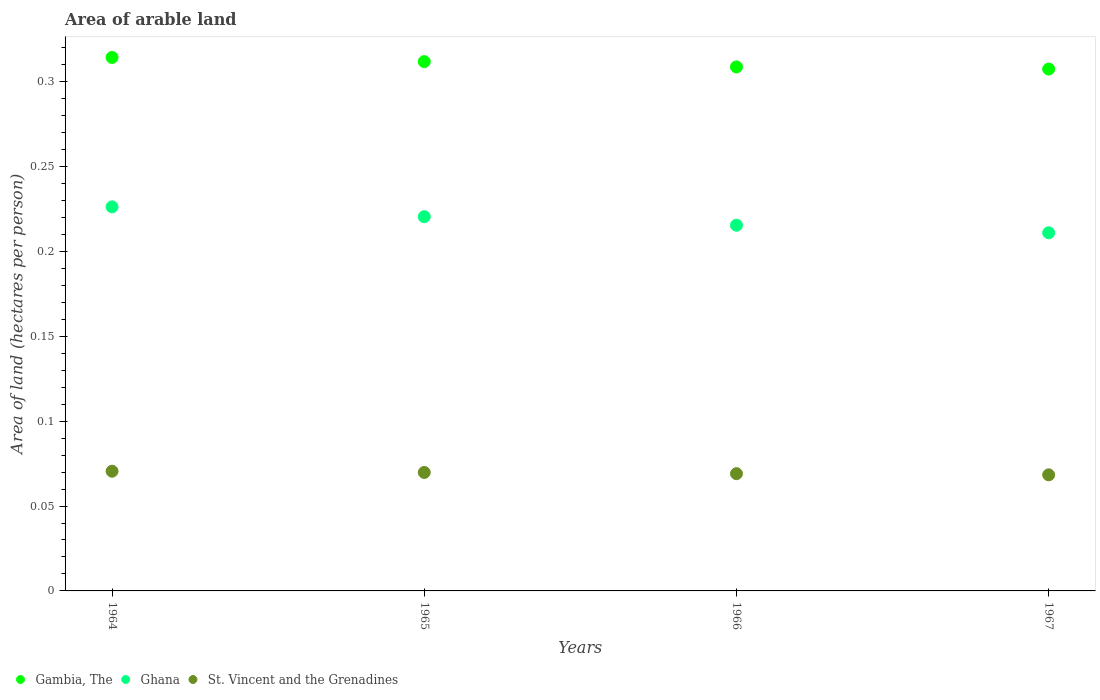How many different coloured dotlines are there?
Offer a terse response. 3. What is the total arable land in St. Vincent and the Grenadines in 1964?
Make the answer very short. 0.07. Across all years, what is the maximum total arable land in St. Vincent and the Grenadines?
Your answer should be compact. 0.07. Across all years, what is the minimum total arable land in St. Vincent and the Grenadines?
Your answer should be very brief. 0.07. In which year was the total arable land in Gambia, The maximum?
Make the answer very short. 1964. In which year was the total arable land in Ghana minimum?
Keep it short and to the point. 1967. What is the total total arable land in Ghana in the graph?
Offer a terse response. 0.87. What is the difference between the total arable land in Ghana in 1965 and that in 1966?
Provide a short and direct response. 0.01. What is the difference between the total arable land in Ghana in 1966 and the total arable land in Gambia, The in 1967?
Your answer should be compact. -0.09. What is the average total arable land in Gambia, The per year?
Provide a succinct answer. 0.31. In the year 1964, what is the difference between the total arable land in St. Vincent and the Grenadines and total arable land in Ghana?
Offer a very short reply. -0.16. What is the ratio of the total arable land in Gambia, The in 1964 to that in 1966?
Provide a succinct answer. 1.02. Is the total arable land in Ghana in 1966 less than that in 1967?
Ensure brevity in your answer.  No. What is the difference between the highest and the second highest total arable land in Gambia, The?
Your answer should be compact. 0. What is the difference between the highest and the lowest total arable land in Gambia, The?
Make the answer very short. 0.01. In how many years, is the total arable land in St. Vincent and the Grenadines greater than the average total arable land in St. Vincent and the Grenadines taken over all years?
Offer a terse response. 2. Is the sum of the total arable land in St. Vincent and the Grenadines in 1965 and 1966 greater than the maximum total arable land in Ghana across all years?
Provide a short and direct response. No. Does the total arable land in St. Vincent and the Grenadines monotonically increase over the years?
Provide a short and direct response. No. Is the total arable land in Gambia, The strictly less than the total arable land in St. Vincent and the Grenadines over the years?
Your answer should be compact. No. How many years are there in the graph?
Your answer should be very brief. 4. What is the difference between two consecutive major ticks on the Y-axis?
Offer a terse response. 0.05. Are the values on the major ticks of Y-axis written in scientific E-notation?
Give a very brief answer. No. How many legend labels are there?
Keep it short and to the point. 3. How are the legend labels stacked?
Ensure brevity in your answer.  Horizontal. What is the title of the graph?
Your answer should be very brief. Area of arable land. Does "Caribbean small states" appear as one of the legend labels in the graph?
Offer a very short reply. No. What is the label or title of the Y-axis?
Your response must be concise. Area of land (hectares per person). What is the Area of land (hectares per person) of Gambia, The in 1964?
Ensure brevity in your answer.  0.31. What is the Area of land (hectares per person) in Ghana in 1964?
Your answer should be very brief. 0.23. What is the Area of land (hectares per person) in St. Vincent and the Grenadines in 1964?
Offer a terse response. 0.07. What is the Area of land (hectares per person) in Gambia, The in 1965?
Provide a succinct answer. 0.31. What is the Area of land (hectares per person) in Ghana in 1965?
Give a very brief answer. 0.22. What is the Area of land (hectares per person) of St. Vincent and the Grenadines in 1965?
Provide a succinct answer. 0.07. What is the Area of land (hectares per person) of Gambia, The in 1966?
Keep it short and to the point. 0.31. What is the Area of land (hectares per person) in Ghana in 1966?
Offer a very short reply. 0.22. What is the Area of land (hectares per person) of St. Vincent and the Grenadines in 1966?
Offer a very short reply. 0.07. What is the Area of land (hectares per person) of Gambia, The in 1967?
Offer a very short reply. 0.31. What is the Area of land (hectares per person) of Ghana in 1967?
Keep it short and to the point. 0.21. What is the Area of land (hectares per person) of St. Vincent and the Grenadines in 1967?
Your answer should be very brief. 0.07. Across all years, what is the maximum Area of land (hectares per person) of Gambia, The?
Offer a terse response. 0.31. Across all years, what is the maximum Area of land (hectares per person) in Ghana?
Provide a short and direct response. 0.23. Across all years, what is the maximum Area of land (hectares per person) in St. Vincent and the Grenadines?
Provide a succinct answer. 0.07. Across all years, what is the minimum Area of land (hectares per person) in Gambia, The?
Your answer should be very brief. 0.31. Across all years, what is the minimum Area of land (hectares per person) of Ghana?
Ensure brevity in your answer.  0.21. Across all years, what is the minimum Area of land (hectares per person) in St. Vincent and the Grenadines?
Give a very brief answer. 0.07. What is the total Area of land (hectares per person) of Gambia, The in the graph?
Make the answer very short. 1.24. What is the total Area of land (hectares per person) in Ghana in the graph?
Your answer should be compact. 0.87. What is the total Area of land (hectares per person) of St. Vincent and the Grenadines in the graph?
Give a very brief answer. 0.28. What is the difference between the Area of land (hectares per person) of Gambia, The in 1964 and that in 1965?
Keep it short and to the point. 0. What is the difference between the Area of land (hectares per person) in Ghana in 1964 and that in 1965?
Give a very brief answer. 0.01. What is the difference between the Area of land (hectares per person) in St. Vincent and the Grenadines in 1964 and that in 1965?
Make the answer very short. 0. What is the difference between the Area of land (hectares per person) of Gambia, The in 1964 and that in 1966?
Provide a short and direct response. 0.01. What is the difference between the Area of land (hectares per person) of Ghana in 1964 and that in 1966?
Ensure brevity in your answer.  0.01. What is the difference between the Area of land (hectares per person) in St. Vincent and the Grenadines in 1964 and that in 1966?
Make the answer very short. 0. What is the difference between the Area of land (hectares per person) of Gambia, The in 1964 and that in 1967?
Your response must be concise. 0.01. What is the difference between the Area of land (hectares per person) of Ghana in 1964 and that in 1967?
Make the answer very short. 0.02. What is the difference between the Area of land (hectares per person) in St. Vincent and the Grenadines in 1964 and that in 1967?
Ensure brevity in your answer.  0. What is the difference between the Area of land (hectares per person) in Gambia, The in 1965 and that in 1966?
Ensure brevity in your answer.  0. What is the difference between the Area of land (hectares per person) in Ghana in 1965 and that in 1966?
Your answer should be very brief. 0.01. What is the difference between the Area of land (hectares per person) of St. Vincent and the Grenadines in 1965 and that in 1966?
Your answer should be compact. 0. What is the difference between the Area of land (hectares per person) of Gambia, The in 1965 and that in 1967?
Keep it short and to the point. 0. What is the difference between the Area of land (hectares per person) of Ghana in 1965 and that in 1967?
Give a very brief answer. 0.01. What is the difference between the Area of land (hectares per person) in St. Vincent and the Grenadines in 1965 and that in 1967?
Make the answer very short. 0. What is the difference between the Area of land (hectares per person) of Gambia, The in 1966 and that in 1967?
Provide a short and direct response. 0. What is the difference between the Area of land (hectares per person) of Ghana in 1966 and that in 1967?
Your response must be concise. 0. What is the difference between the Area of land (hectares per person) in St. Vincent and the Grenadines in 1966 and that in 1967?
Ensure brevity in your answer.  0. What is the difference between the Area of land (hectares per person) of Gambia, The in 1964 and the Area of land (hectares per person) of Ghana in 1965?
Ensure brevity in your answer.  0.09. What is the difference between the Area of land (hectares per person) in Gambia, The in 1964 and the Area of land (hectares per person) in St. Vincent and the Grenadines in 1965?
Your answer should be compact. 0.24. What is the difference between the Area of land (hectares per person) in Ghana in 1964 and the Area of land (hectares per person) in St. Vincent and the Grenadines in 1965?
Your answer should be compact. 0.16. What is the difference between the Area of land (hectares per person) of Gambia, The in 1964 and the Area of land (hectares per person) of Ghana in 1966?
Make the answer very short. 0.1. What is the difference between the Area of land (hectares per person) in Gambia, The in 1964 and the Area of land (hectares per person) in St. Vincent and the Grenadines in 1966?
Give a very brief answer. 0.25. What is the difference between the Area of land (hectares per person) in Ghana in 1964 and the Area of land (hectares per person) in St. Vincent and the Grenadines in 1966?
Your answer should be very brief. 0.16. What is the difference between the Area of land (hectares per person) in Gambia, The in 1964 and the Area of land (hectares per person) in Ghana in 1967?
Give a very brief answer. 0.1. What is the difference between the Area of land (hectares per person) in Gambia, The in 1964 and the Area of land (hectares per person) in St. Vincent and the Grenadines in 1967?
Offer a terse response. 0.25. What is the difference between the Area of land (hectares per person) of Ghana in 1964 and the Area of land (hectares per person) of St. Vincent and the Grenadines in 1967?
Provide a short and direct response. 0.16. What is the difference between the Area of land (hectares per person) of Gambia, The in 1965 and the Area of land (hectares per person) of Ghana in 1966?
Offer a very short reply. 0.1. What is the difference between the Area of land (hectares per person) of Gambia, The in 1965 and the Area of land (hectares per person) of St. Vincent and the Grenadines in 1966?
Keep it short and to the point. 0.24. What is the difference between the Area of land (hectares per person) in Ghana in 1965 and the Area of land (hectares per person) in St. Vincent and the Grenadines in 1966?
Offer a terse response. 0.15. What is the difference between the Area of land (hectares per person) in Gambia, The in 1965 and the Area of land (hectares per person) in Ghana in 1967?
Provide a succinct answer. 0.1. What is the difference between the Area of land (hectares per person) of Gambia, The in 1965 and the Area of land (hectares per person) of St. Vincent and the Grenadines in 1967?
Your response must be concise. 0.24. What is the difference between the Area of land (hectares per person) of Ghana in 1965 and the Area of land (hectares per person) of St. Vincent and the Grenadines in 1967?
Offer a terse response. 0.15. What is the difference between the Area of land (hectares per person) in Gambia, The in 1966 and the Area of land (hectares per person) in Ghana in 1967?
Offer a very short reply. 0.1. What is the difference between the Area of land (hectares per person) of Gambia, The in 1966 and the Area of land (hectares per person) of St. Vincent and the Grenadines in 1967?
Offer a terse response. 0.24. What is the difference between the Area of land (hectares per person) of Ghana in 1966 and the Area of land (hectares per person) of St. Vincent and the Grenadines in 1967?
Provide a short and direct response. 0.15. What is the average Area of land (hectares per person) of Gambia, The per year?
Ensure brevity in your answer.  0.31. What is the average Area of land (hectares per person) in Ghana per year?
Your answer should be very brief. 0.22. What is the average Area of land (hectares per person) in St. Vincent and the Grenadines per year?
Offer a terse response. 0.07. In the year 1964, what is the difference between the Area of land (hectares per person) of Gambia, The and Area of land (hectares per person) of Ghana?
Make the answer very short. 0.09. In the year 1964, what is the difference between the Area of land (hectares per person) of Gambia, The and Area of land (hectares per person) of St. Vincent and the Grenadines?
Your response must be concise. 0.24. In the year 1964, what is the difference between the Area of land (hectares per person) of Ghana and Area of land (hectares per person) of St. Vincent and the Grenadines?
Keep it short and to the point. 0.16. In the year 1965, what is the difference between the Area of land (hectares per person) in Gambia, The and Area of land (hectares per person) in Ghana?
Your answer should be compact. 0.09. In the year 1965, what is the difference between the Area of land (hectares per person) of Gambia, The and Area of land (hectares per person) of St. Vincent and the Grenadines?
Make the answer very short. 0.24. In the year 1965, what is the difference between the Area of land (hectares per person) of Ghana and Area of land (hectares per person) of St. Vincent and the Grenadines?
Your answer should be compact. 0.15. In the year 1966, what is the difference between the Area of land (hectares per person) in Gambia, The and Area of land (hectares per person) in Ghana?
Provide a short and direct response. 0.09. In the year 1966, what is the difference between the Area of land (hectares per person) in Gambia, The and Area of land (hectares per person) in St. Vincent and the Grenadines?
Your response must be concise. 0.24. In the year 1966, what is the difference between the Area of land (hectares per person) in Ghana and Area of land (hectares per person) in St. Vincent and the Grenadines?
Offer a very short reply. 0.15. In the year 1967, what is the difference between the Area of land (hectares per person) of Gambia, The and Area of land (hectares per person) of Ghana?
Offer a very short reply. 0.1. In the year 1967, what is the difference between the Area of land (hectares per person) in Gambia, The and Area of land (hectares per person) in St. Vincent and the Grenadines?
Provide a short and direct response. 0.24. In the year 1967, what is the difference between the Area of land (hectares per person) of Ghana and Area of land (hectares per person) of St. Vincent and the Grenadines?
Your answer should be very brief. 0.14. What is the ratio of the Area of land (hectares per person) of Gambia, The in 1964 to that in 1965?
Make the answer very short. 1.01. What is the ratio of the Area of land (hectares per person) in Ghana in 1964 to that in 1965?
Your answer should be very brief. 1.03. What is the ratio of the Area of land (hectares per person) of St. Vincent and the Grenadines in 1964 to that in 1965?
Provide a succinct answer. 1.01. What is the ratio of the Area of land (hectares per person) of Gambia, The in 1964 to that in 1966?
Offer a very short reply. 1.02. What is the ratio of the Area of land (hectares per person) of Ghana in 1964 to that in 1966?
Offer a very short reply. 1.05. What is the ratio of the Area of land (hectares per person) of St. Vincent and the Grenadines in 1964 to that in 1966?
Your answer should be very brief. 1.02. What is the ratio of the Area of land (hectares per person) in Gambia, The in 1964 to that in 1967?
Provide a succinct answer. 1.02. What is the ratio of the Area of land (hectares per person) of Ghana in 1964 to that in 1967?
Your answer should be very brief. 1.07. What is the ratio of the Area of land (hectares per person) of St. Vincent and the Grenadines in 1964 to that in 1967?
Keep it short and to the point. 1.03. What is the ratio of the Area of land (hectares per person) in Gambia, The in 1965 to that in 1966?
Offer a terse response. 1.01. What is the ratio of the Area of land (hectares per person) in Ghana in 1965 to that in 1966?
Your response must be concise. 1.02. What is the ratio of the Area of land (hectares per person) of St. Vincent and the Grenadines in 1965 to that in 1966?
Give a very brief answer. 1.01. What is the ratio of the Area of land (hectares per person) in Gambia, The in 1965 to that in 1967?
Ensure brevity in your answer.  1.01. What is the ratio of the Area of land (hectares per person) of Ghana in 1965 to that in 1967?
Give a very brief answer. 1.04. What is the ratio of the Area of land (hectares per person) of St. Vincent and the Grenadines in 1965 to that in 1967?
Ensure brevity in your answer.  1.02. What is the ratio of the Area of land (hectares per person) in Gambia, The in 1966 to that in 1967?
Offer a terse response. 1. What is the ratio of the Area of land (hectares per person) of Ghana in 1966 to that in 1967?
Offer a very short reply. 1.02. What is the difference between the highest and the second highest Area of land (hectares per person) in Gambia, The?
Provide a succinct answer. 0. What is the difference between the highest and the second highest Area of land (hectares per person) of Ghana?
Your answer should be very brief. 0.01. What is the difference between the highest and the second highest Area of land (hectares per person) of St. Vincent and the Grenadines?
Offer a terse response. 0. What is the difference between the highest and the lowest Area of land (hectares per person) of Gambia, The?
Provide a short and direct response. 0.01. What is the difference between the highest and the lowest Area of land (hectares per person) of Ghana?
Make the answer very short. 0.02. What is the difference between the highest and the lowest Area of land (hectares per person) of St. Vincent and the Grenadines?
Keep it short and to the point. 0. 